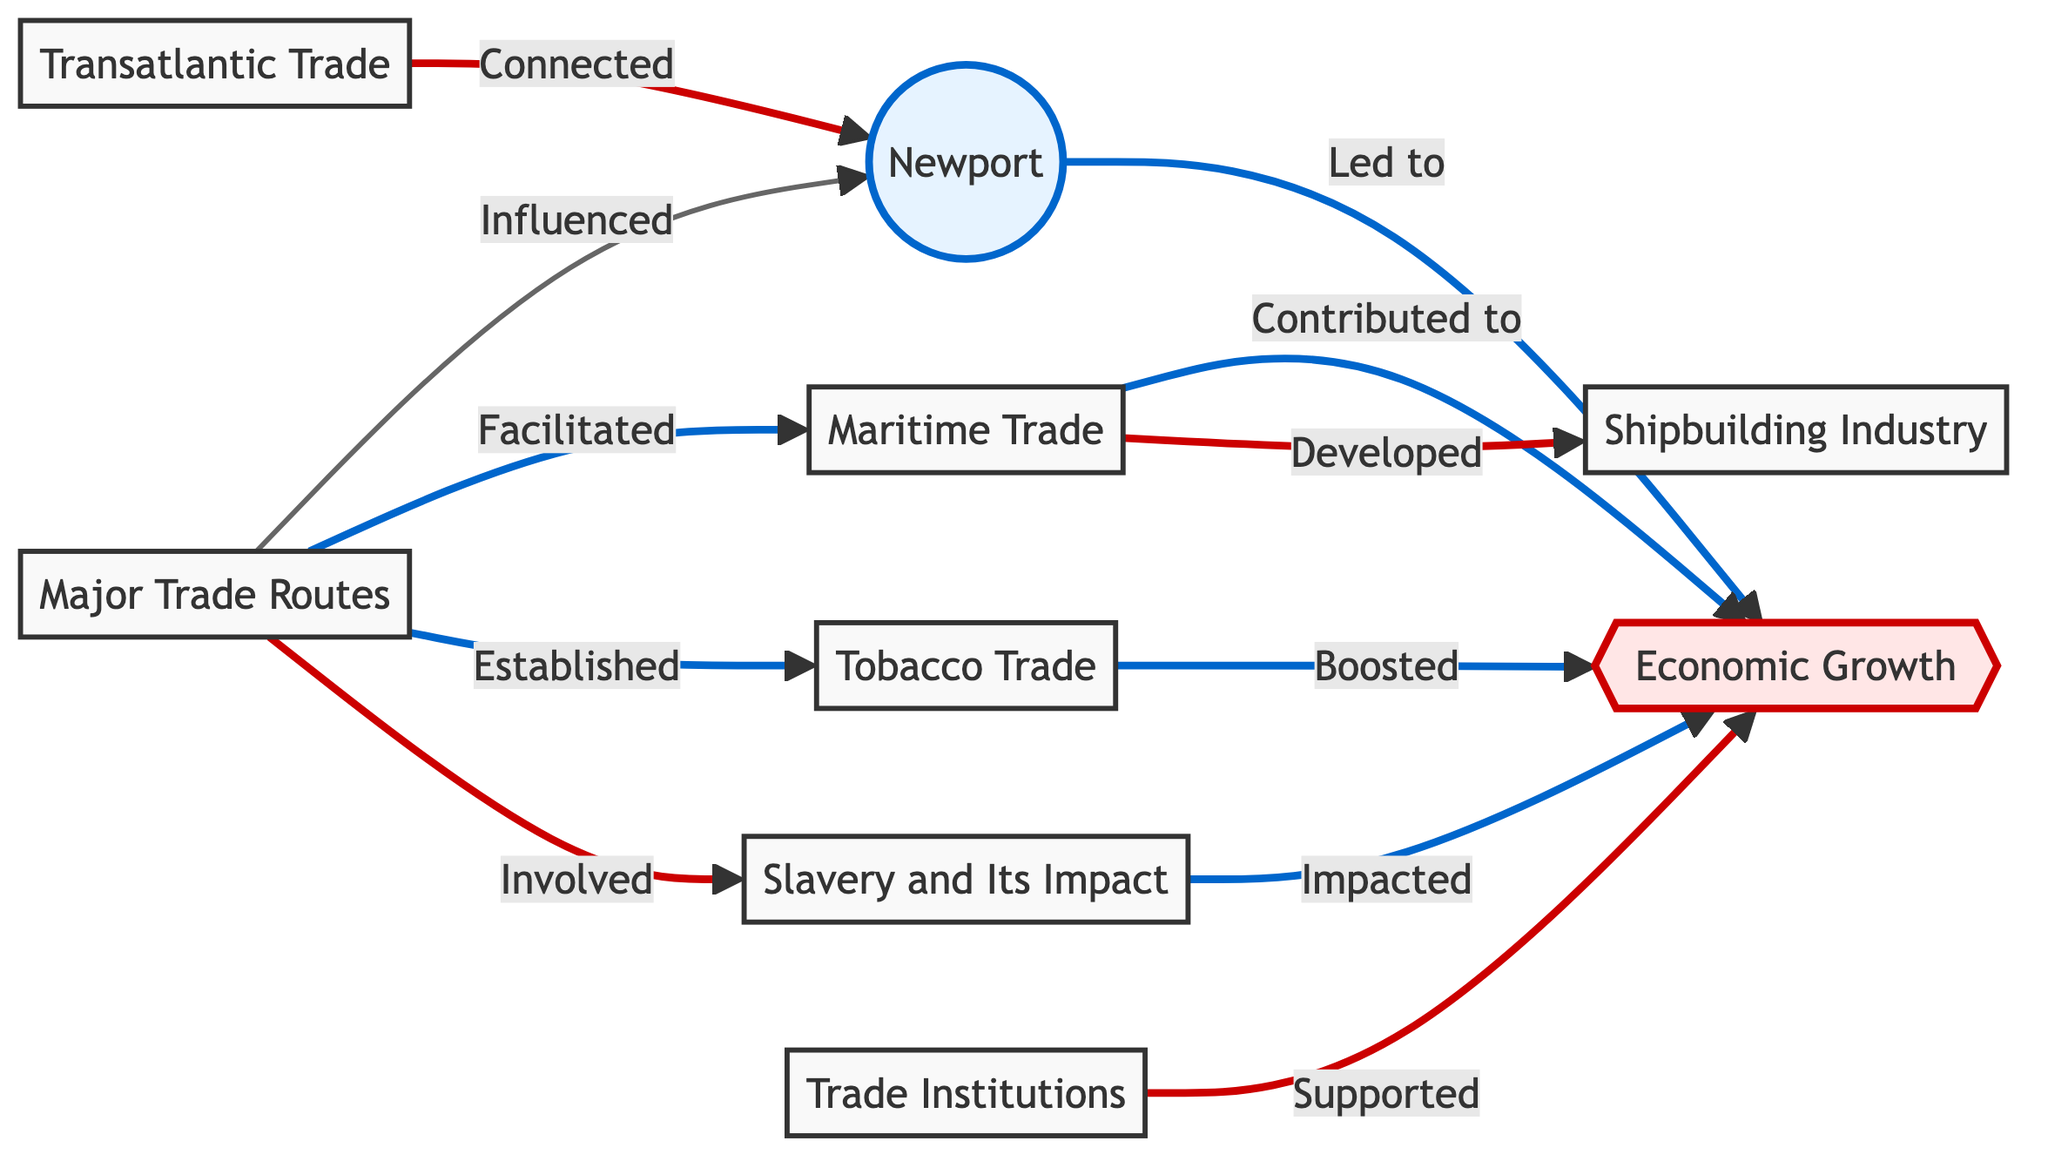What node directly influences Newport? The diagram shows an arrow from "Major Trade Routes" to "Newport," indicating it directly influences Newport.
Answer: Major Trade Routes How many total nodes are in the diagram? By counting the labeled nodes in the diagram, we find there are 8 nodes: Newport, Major Trade Routes, Maritime Trade, Economic Growth, Shipbuilding Industry, Tobacco Trade, Slavery and Its Impact, Transatlantic Trade, and Trade Institutions.
Answer: 8 Which trade route is associated with the shipbuilding industry? The diagram shows that "Maritime Trade" is connected to "Shipbuilding Industry," indicating this trade route is associated with shipbuilding.
Answer: Maritime Trade What directly contributes to Newport's economic growth? There are multiple connections leading to "Economic Growth," particularly from "Newport," "Maritime Trade," "Tobacco Trade," and "Slavery," indicating these are direct contributors.
Answer: Newport, Maritime Trade, Tobacco Trade, Slavery Which node connects Newport to transatlantic shipping? The diagram illustrates a direct link from "Transatlantic Trade" to "Newport," indicating this node connects Newport to transatlantic shipping.
Answer: Transatlantic Trade What factor has the strongest negative impact on economic growth? The diagram highlights a connection from "Slavery" to "Economic Growth," indicating slavery has a significant or negative impact on economic growth among the factors listed.
Answer: Slavery Which node is supported by trade institutions? The arrow from "Trade Institutions" points to "Economic Growth," indicating that trade institutions support economic growth.
Answer: Economic Growth How many edges are connected to tobacco trade? By looking at the diagram, "Tobacco Trade" has one edge leading to "Economic Growth" and one from "Major Trade Routes," totaling two edges.
Answer: 2 Which node initiated the development of the maritime trade? The edge shows that "Major Trade Routes" facilitated "Maritime Trade," indicating it is the initiator of the development.
Answer: Major Trade Routes 